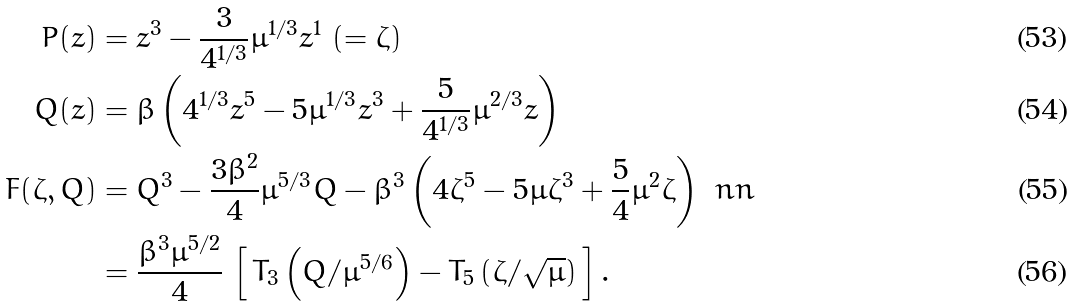Convert formula to latex. <formula><loc_0><loc_0><loc_500><loc_500>P ( z ) & = z ^ { 3 } - \frac { 3 } { 4 ^ { 1 / 3 } } \mu ^ { 1 / 3 } z ^ { 1 } \, \left ( = \zeta \right ) \\ Q ( z ) & = \beta \left ( 4 ^ { 1 / 3 } z ^ { 5 } - 5 \mu ^ { 1 / 3 } z ^ { 3 } + \frac { 5 } { 4 ^ { 1 / 3 } } \mu ^ { 2 / 3 } z \right ) \\ F ( \zeta , Q ) & = Q ^ { 3 } - \frac { 3 \beta ^ { 2 } } { 4 } \mu ^ { 5 / 3 } Q - \beta ^ { 3 } \left ( 4 \zeta ^ { 5 } - 5 \mu \zeta ^ { 3 } + \frac { 5 } { 4 } \mu ^ { 2 } \zeta \right ) \ n n \\ & = \frac { \beta ^ { 3 } \mu ^ { 5 / 2 } } { 4 } \, \left [ \, T _ { 3 } \left ( Q / \mu ^ { 5 / 6 } \right ) - T _ { 5 } \left ( \zeta / \sqrt { \mu } \right ) \, \right ] .</formula> 